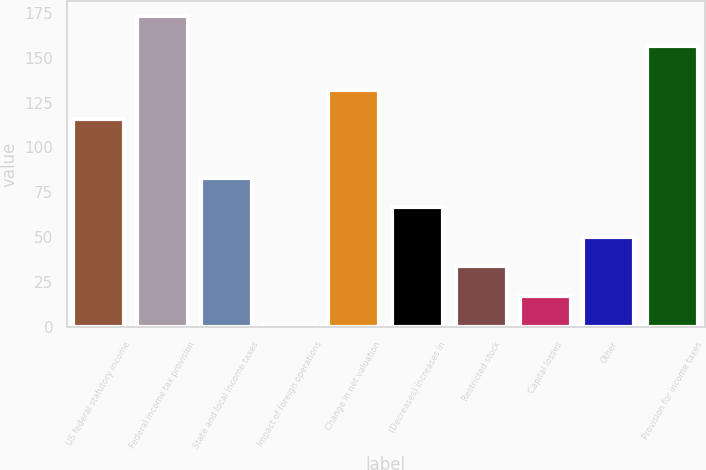Convert chart to OTSL. <chart><loc_0><loc_0><loc_500><loc_500><bar_chart><fcel>US federal statutory income<fcel>Federal income tax provision<fcel>State and local income taxes<fcel>Impact of foreign operations<fcel>Change in net valuation<fcel>(Decreases) increases in<fcel>Restricted stock<fcel>Capital losses<fcel>Other<fcel>Provision for income taxes<nl><fcel>115.77<fcel>173.01<fcel>82.95<fcel>0.9<fcel>132.18<fcel>66.54<fcel>33.72<fcel>17.31<fcel>50.13<fcel>156.6<nl></chart> 